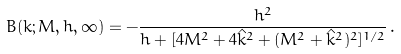<formula> <loc_0><loc_0><loc_500><loc_500>B ( k ; M , h , \infty ) = - \frac { h ^ { 2 } } { h + [ 4 M ^ { 2 } + 4 \hat { k } ^ { 2 } + ( M ^ { 2 } + \hat { k } ^ { 2 } ) ^ { 2 } ] ^ { 1 / 2 } } \, .</formula> 